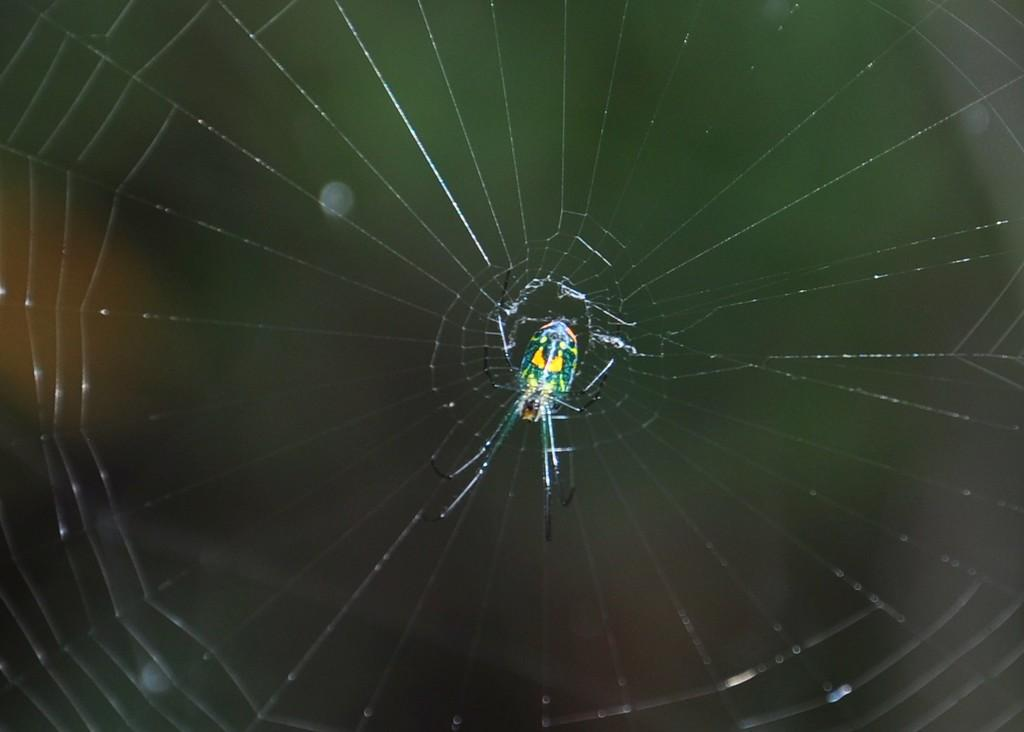What is the main subject of the image? There is a spider in the image. What is associated with the spider in the image? There is a spider web in the image. Can you describe the background of the image? The background of the image is blurred. What type of boot is visible in the image? There is no boot present in the image. What kind of cloth is used to make the spider's skin in the image? Spiders do not have skin made of cloth; they have an exoskeleton. 